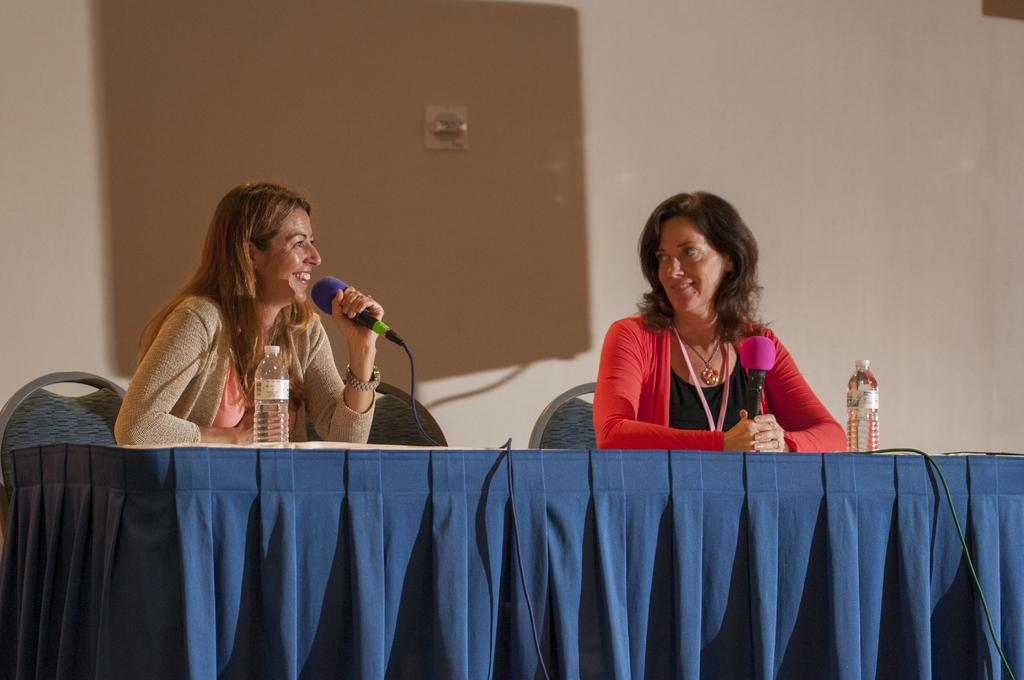What is the color of the wall in the image? The wall in the image is white. What are the people in the image doing? The two people are sitting on chairs in the image. What is located in front of the chairs? There is a table in front of the chairs. What objects can be seen on the table? There are bottles on the table. What type of pleasure can be seen on the faces of the people in the image? There is no indication of pleasure on the faces of the people in the image, as their expressions are not visible. 